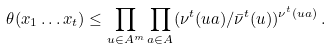Convert formula to latex. <formula><loc_0><loc_0><loc_500><loc_500>\theta ( x _ { 1 } \dots x _ { t } ) \leq \prod _ { u \in A ^ { m } } \prod _ { a \in A } ( \nu ^ { t } ( u a ) / \bar { \nu } ^ { t } ( u ) ) ^ { \nu ^ { t } ( u a ) } \, .</formula> 